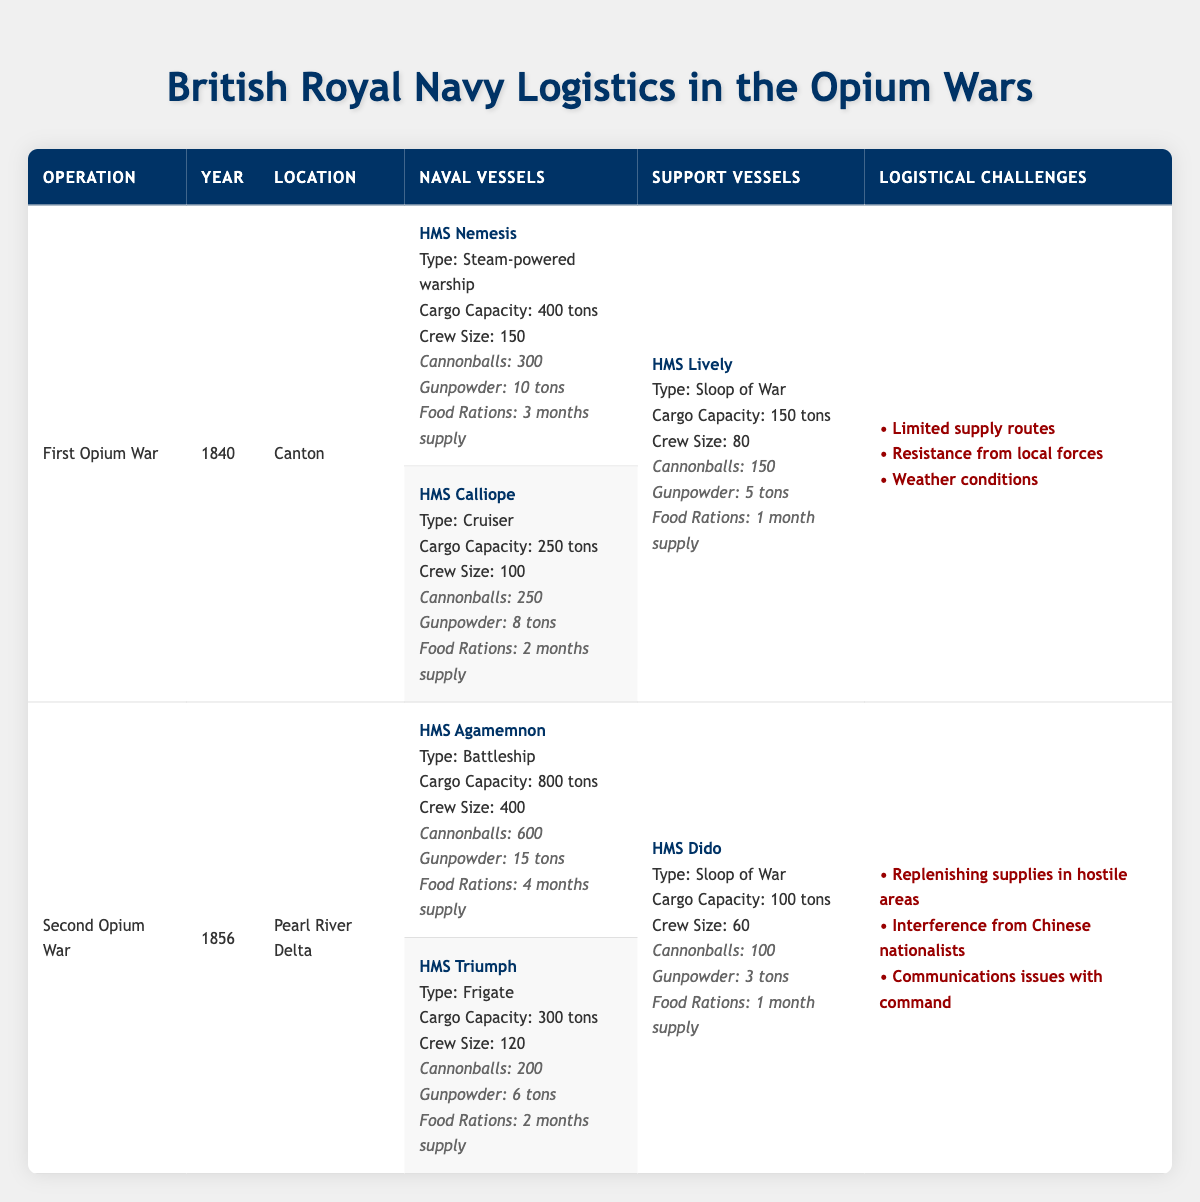What was the location of the First Opium War? The location can be found directly in the table under the First Opium War, which is listed as Canton.
Answer: Canton How many crew members did HMS Agamemnon have? HMS Agamemnon's crew size is stated directly in the table, listed as 400.
Answer: 400 What is the cargo capacity of HMS Calliope? The cargo capacity of HMS Calliope is mentioned in the table, which shows it as 250 tons.
Answer: 250 tons Which vessel had the greatest number of cannonballs during the Second Opium War? In the table, HMS Agamemnon has the highest number of cannonballs, which is 600, compared to HMS Triumph and HMS Dido.
Answer: HMS Agamemnon What percentage of cannonballs did HMS Triumph have compared to HMS Agamemnon? HMS Triumph has 200 cannonballs and HMS Agamemnon has 600. To find the percentage: (200/600) * 100 = 33.33%.
Answer: 33.33% Is it true that the HMS Lively had more food rations than HMS Calliope? HMS Lively had a supply of 1 month, while HMS Calliope had 2 months. Therefore, the statement is false.
Answer: No How many months of food rations were provided by all naval vessels combined in the First Opium War? For the naval vessels: HMS Nemesis had 3 months, and HMS Calliope had 2 months. Therefore, the total is 3 + 2 = 5 months.
Answer: 5 months What were the three logistical challenges faced during the Second Opium War? The table lists the logistical challenges for the Second Opium War as: Replenishing supplies in hostile areas, Interference from Chinese nationalists, and Communications issues with command.
Answer: Replenishing supplies in hostile areas, Interference from Chinese nationalists, Communications issues with command Which operation had a larger cargo capacity across its vessels, the First Opium War or the Second Opium War? First Opium War vessels have a total capacity of 400 + 250 + 150 = 800 tons. Second Opium War vessels have 800 + 300 + 100 = 1200 tons. Since 1200 tons is greater, the Second Opium War had a larger capacity.
Answer: Second Opium War What is the total crew size of the support vessels in the First Opium War? The support vessel in the First Opium War is HMS Lively which has a crew size of 80. Therefore, the total crew size for support vessels in this war is 80.
Answer: 80 